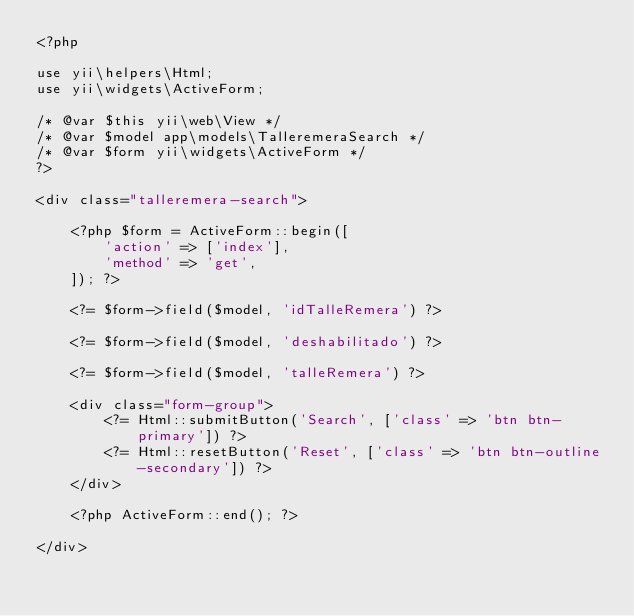<code> <loc_0><loc_0><loc_500><loc_500><_PHP_><?php

use yii\helpers\Html;
use yii\widgets\ActiveForm;

/* @var $this yii\web\View */
/* @var $model app\models\TalleremeraSearch */
/* @var $form yii\widgets\ActiveForm */
?>

<div class="talleremera-search">

    <?php $form = ActiveForm::begin([
        'action' => ['index'],
        'method' => 'get',
    ]); ?>

    <?= $form->field($model, 'idTalleRemera') ?>

    <?= $form->field($model, 'deshabilitado') ?>

    <?= $form->field($model, 'talleRemera') ?>

    <div class="form-group">
        <?= Html::submitButton('Search', ['class' => 'btn btn-primary']) ?>
        <?= Html::resetButton('Reset', ['class' => 'btn btn-outline-secondary']) ?>
    </div>

    <?php ActiveForm::end(); ?>

</div>
</code> 